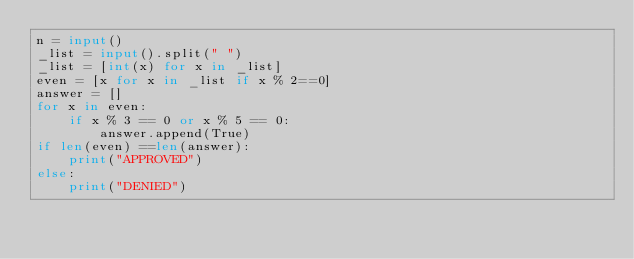<code> <loc_0><loc_0><loc_500><loc_500><_Python_>n = input()
_list = input().split(" ")
_list = [int(x) for x in _list]
even = [x for x in _list if x % 2==0]
answer = []
for x in even:
    if x % 3 == 0 or x % 5 == 0:
        answer.append(True)
if len(even) ==len(answer):
    print("APPROVED")
else:
    print("DENIED")</code> 